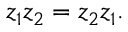<formula> <loc_0><loc_0><loc_500><loc_500>z _ { 1 } z _ { 2 } = z _ { 2 } z _ { 1 } .</formula> 